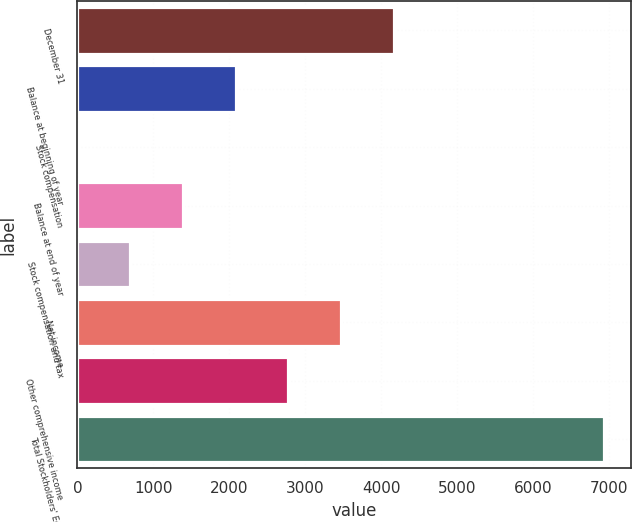Convert chart to OTSL. <chart><loc_0><loc_0><loc_500><loc_500><bar_chart><fcel>December 31<fcel>Balance at beginning of year<fcel>Stock compensation<fcel>Balance at end of year<fcel>Stock compensation and tax<fcel>Net income<fcel>Other comprehensive income<fcel>Total Stockholders' Equity<nl><fcel>4164.52<fcel>2082.61<fcel>0.7<fcel>1388.64<fcel>694.67<fcel>3470.55<fcel>2776.58<fcel>6940.4<nl></chart> 